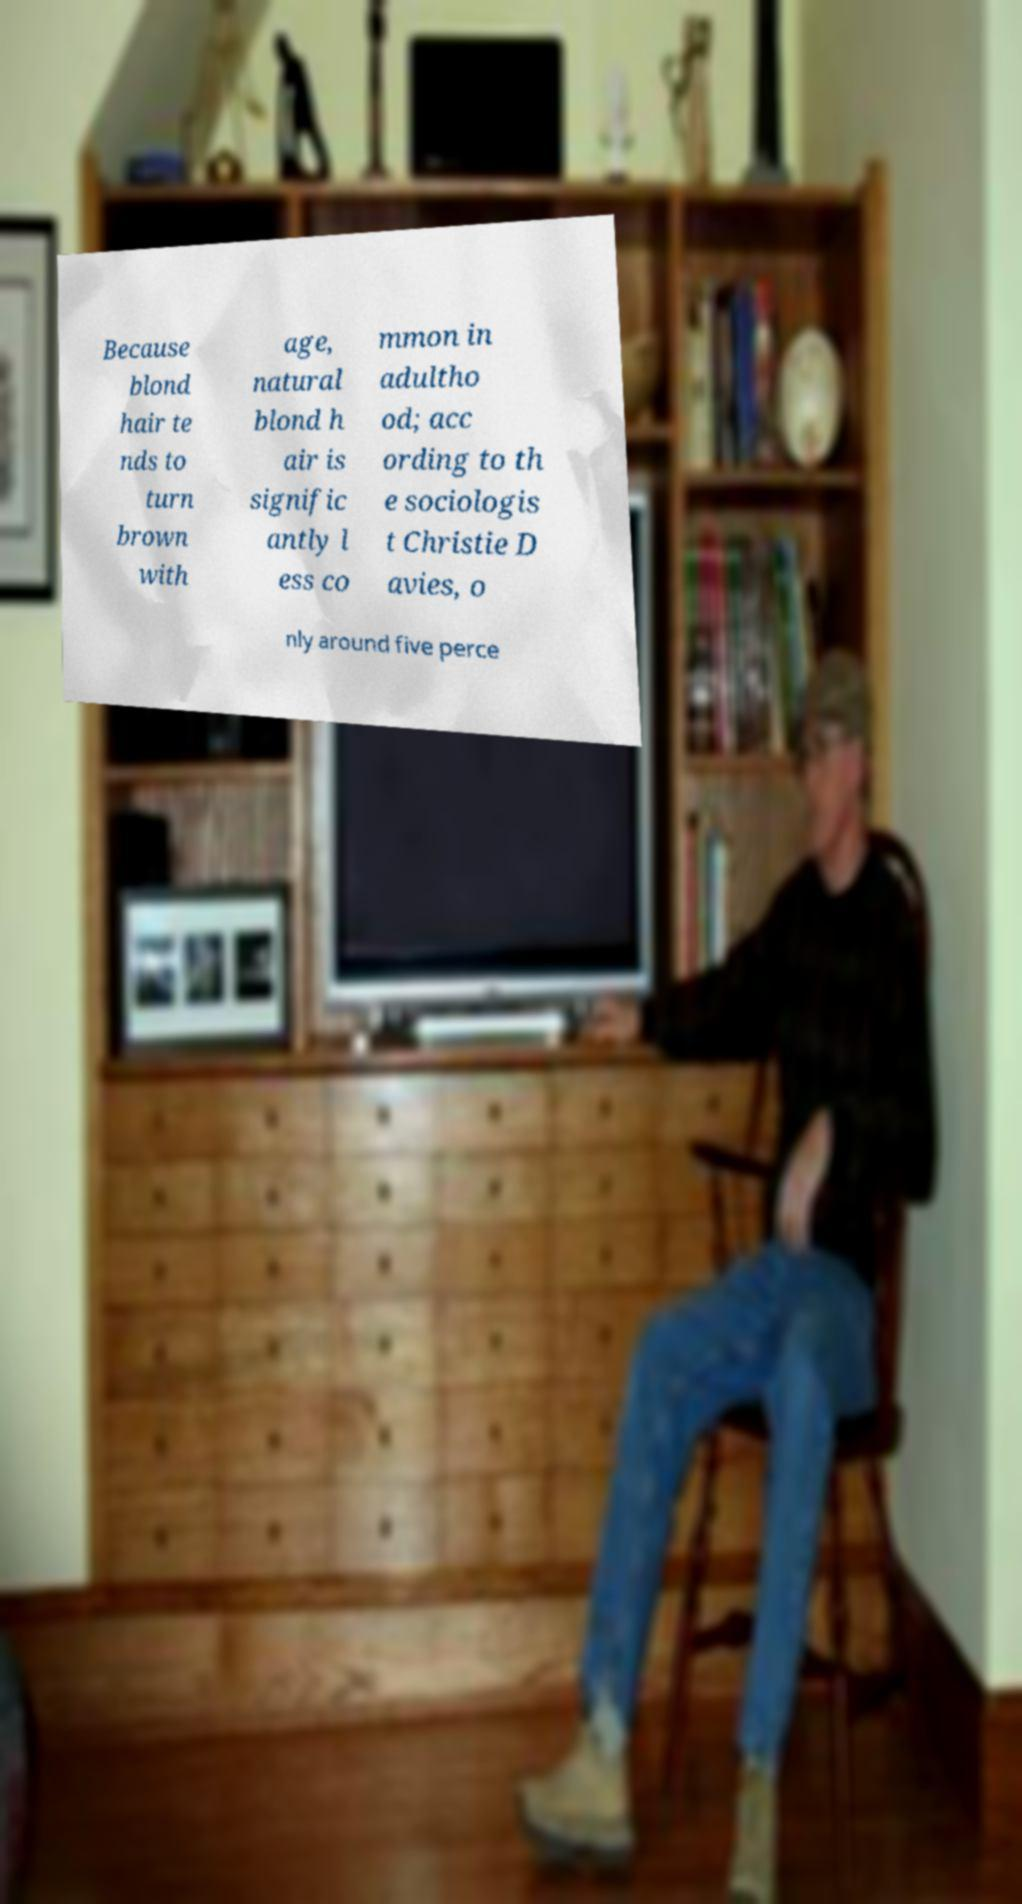For documentation purposes, I need the text within this image transcribed. Could you provide that? Because blond hair te nds to turn brown with age, natural blond h air is signific antly l ess co mmon in adultho od; acc ording to th e sociologis t Christie D avies, o nly around five perce 